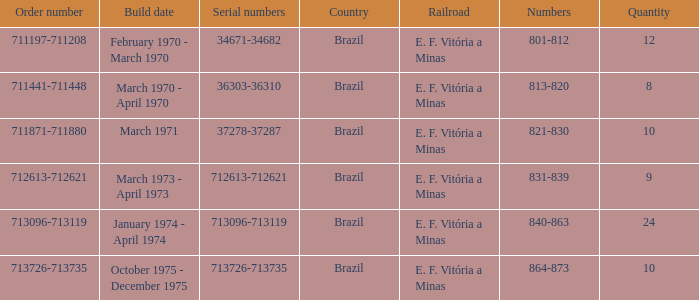Write the full table. {'header': ['Order number', 'Build date', 'Serial numbers', 'Country', 'Railroad', 'Numbers', 'Quantity'], 'rows': [['711197-711208', 'February 1970 - March 1970', '34671-34682', 'Brazil', 'E. F. Vitória a Minas', '801-812', '12'], ['711441-711448', 'March 1970 - April 1970', '36303-36310', 'Brazil', 'E. F. Vitória a Minas', '813-820', '8'], ['711871-711880', 'March 1971', '37278-37287', 'Brazil', 'E. F. Vitória a Minas', '821-830', '10'], ['712613-712621', 'March 1973 - April 1973', '712613-712621', 'Brazil', 'E. F. Vitória a Minas', '831-839', '9'], ['713096-713119', 'January 1974 - April 1974', '713096-713119', 'Brazil', 'E. F. Vitória a Minas', '840-863', '24'], ['713726-713735', 'October 1975 - December 1975', '713726-713735', 'Brazil', 'E. F. Vitória a Minas', '864-873', '10']]} What are the numbers for the order number 713096-713119? 840-863. 